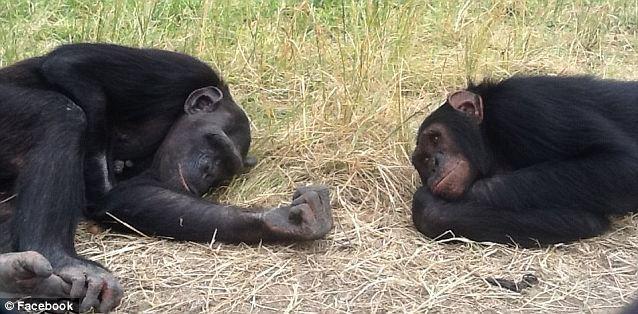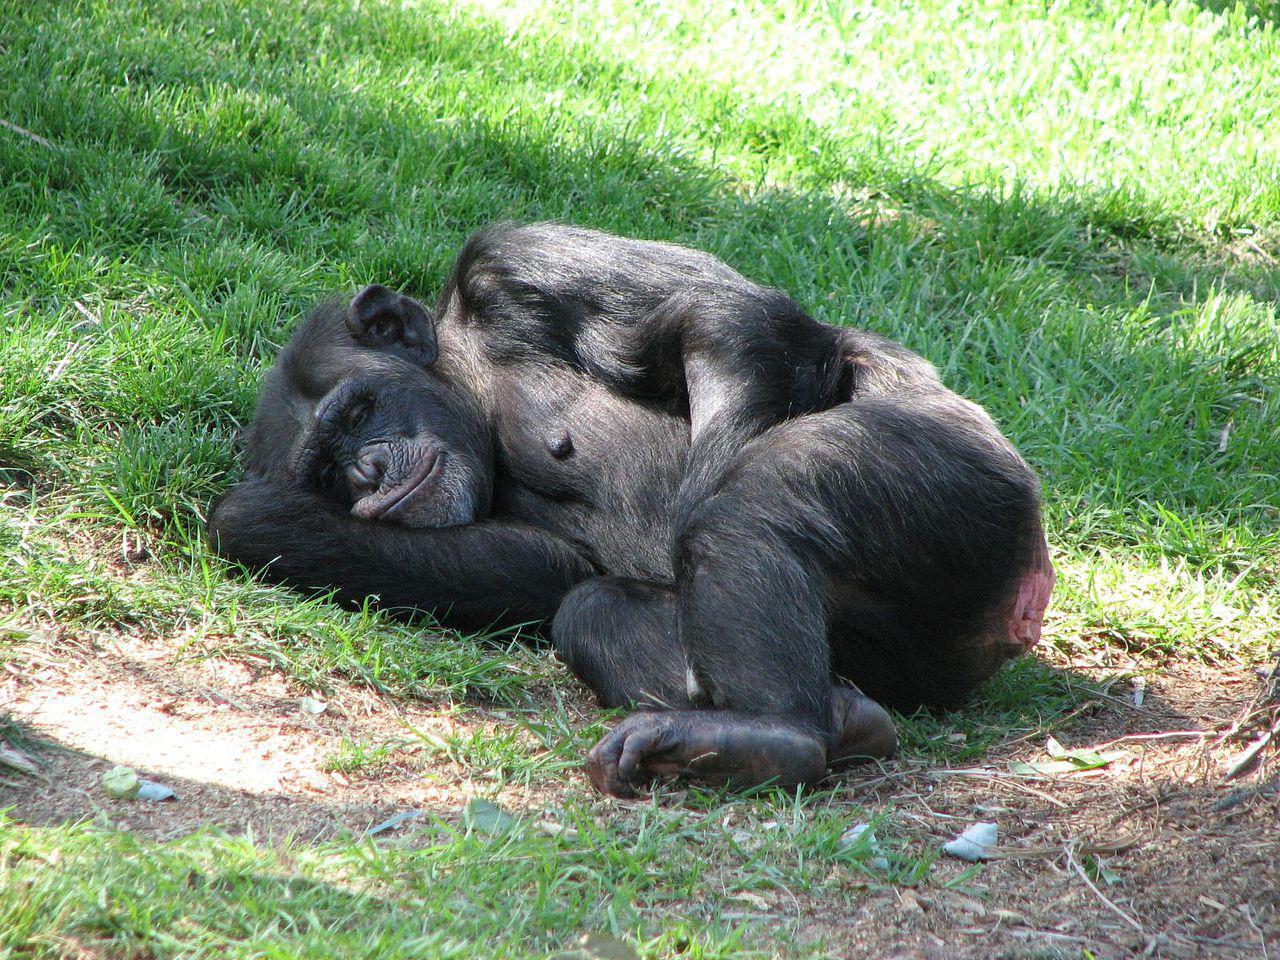The first image is the image on the left, the second image is the image on the right. Examine the images to the left and right. Is the description "The left image has at least one chimp lying down." accurate? Answer yes or no. Yes. The first image is the image on the left, the second image is the image on the right. For the images shown, is this caption "A chimpanzee sleeps alone." true? Answer yes or no. Yes. 